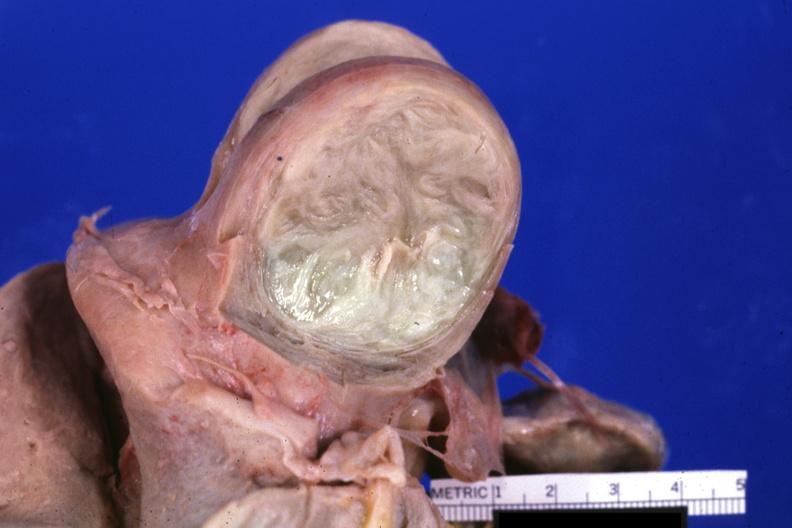does this image show fixed tissue cut surface of typical myoma?
Answer the question using a single word or phrase. Yes 